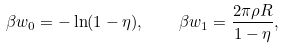Convert formula to latex. <formula><loc_0><loc_0><loc_500><loc_500>\beta w _ { 0 } = - \ln ( 1 - \eta ) , \quad \beta w _ { 1 } = \frac { 2 \pi \rho R } { 1 - \eta } ,</formula> 